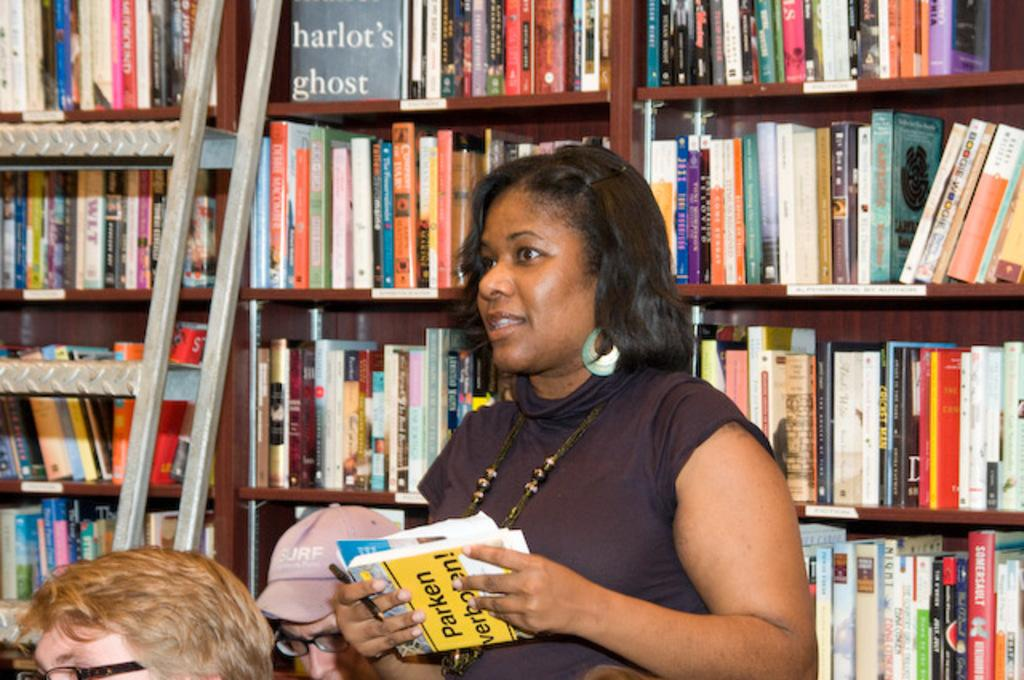Who is the main subject in the image? There is a woman in the center of the image. What is the woman holding in the image? The woman is holding a pen. What else can be seen in the image besides the woman? There are books and two persons on the left side of the image. What is visible in the background of the image? There are many books placed on a rack in the background of the image. What type of club is the woman holding in the image? There is no club present in the image; the woman is holding a pen. 